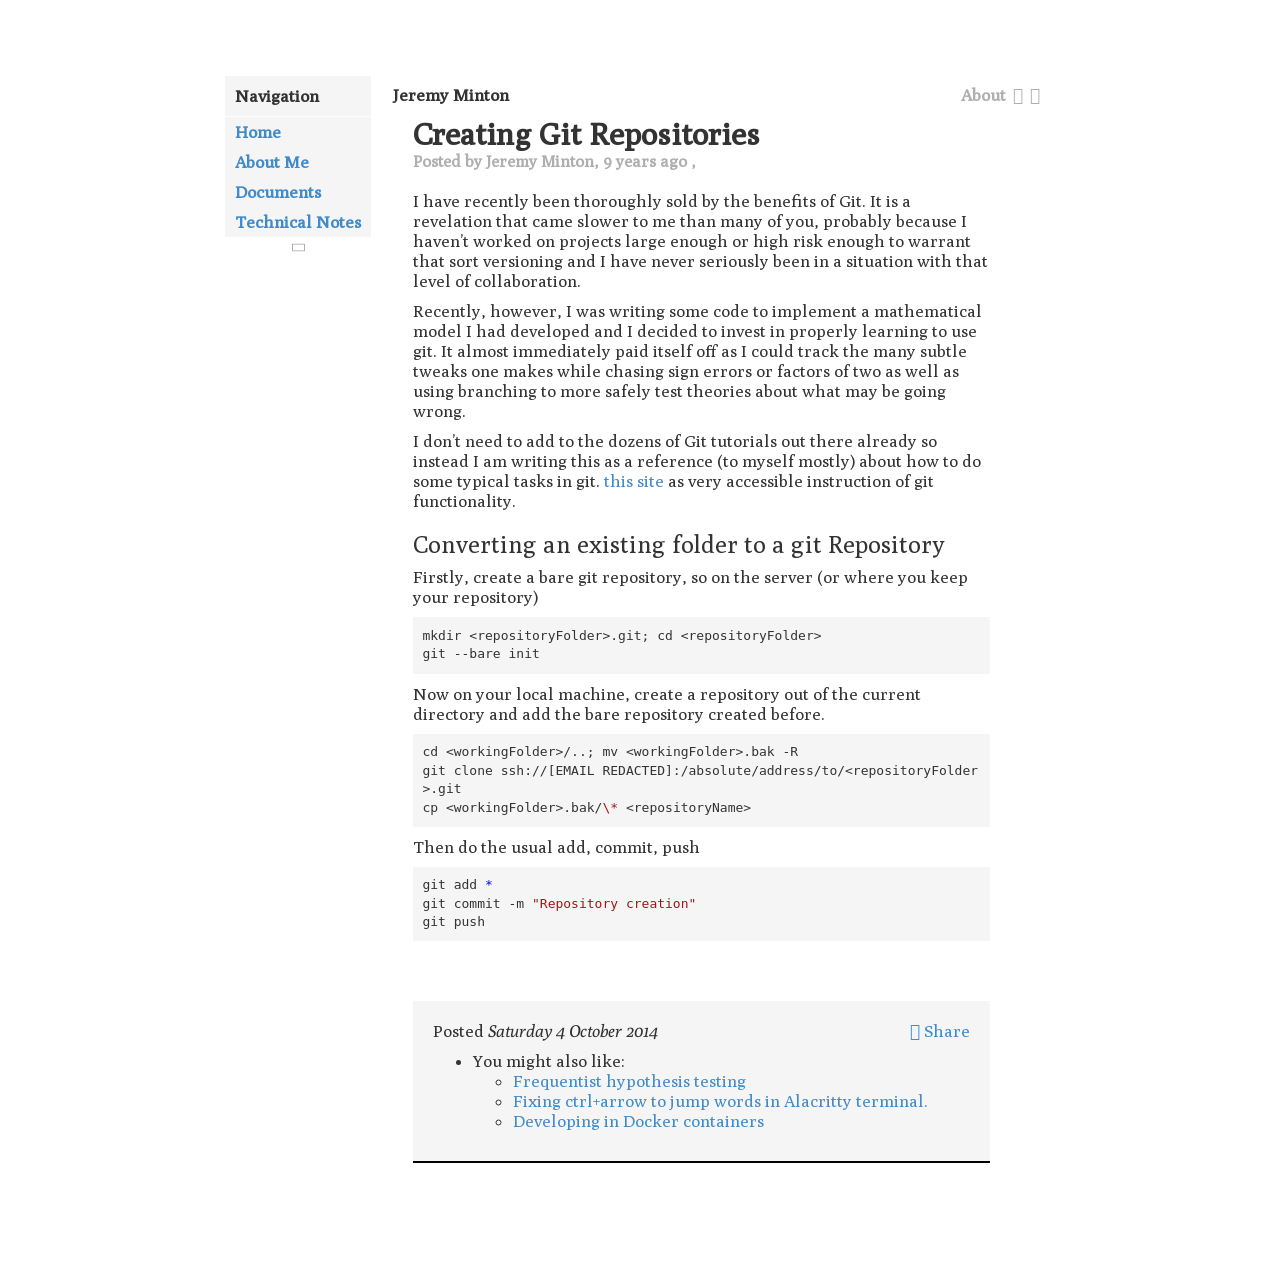Can you explain the main topic discussed on this webpage? The webpage discusses the process of creating Git repositories, an essential concept in software development that helps in version control and managing changes to projects.  What steps are mentioned for converting an existing folder into a Git repository? The steps include creating a bare Git repository on the server, initializing Git in your project's directory on your local machine, linking these repositories, and then pushing your local changes up to the remote repository. 